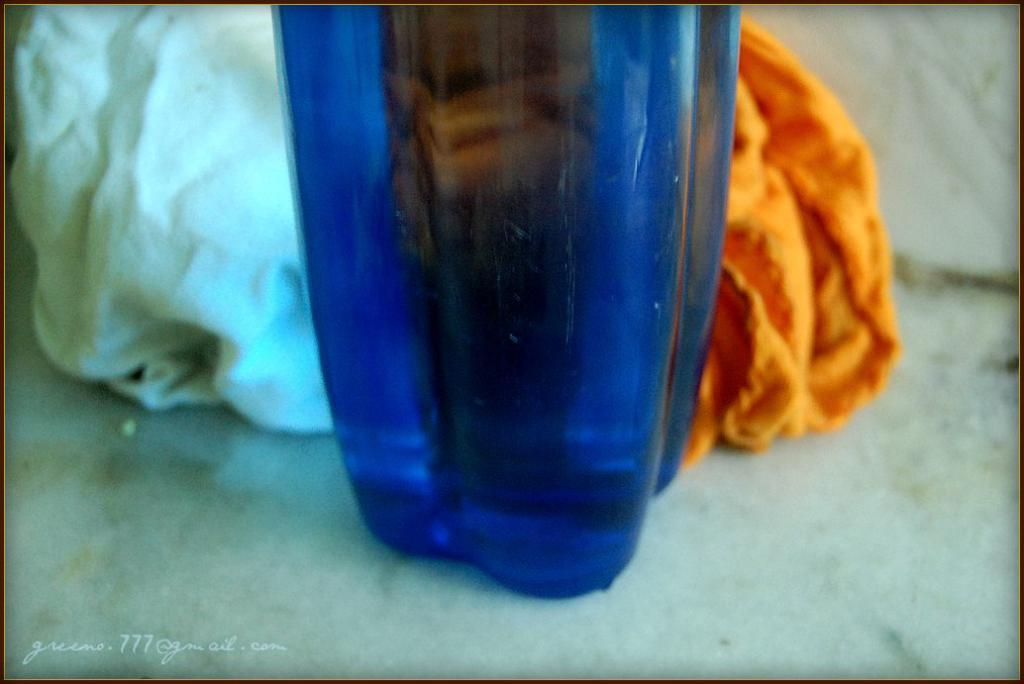What color is the water bottle in the image? The water bottle in the image is blue. Where is the water bottle located in the image? The water bottle is on a white floor. What type of crime is being committed by the crow in the image? There is no crow present in the image, and therefore no crime is being committed. What color is the paint on the wall in the image? There is no wall or paint present in the image; it only features a blue water bottle on a white floor. 